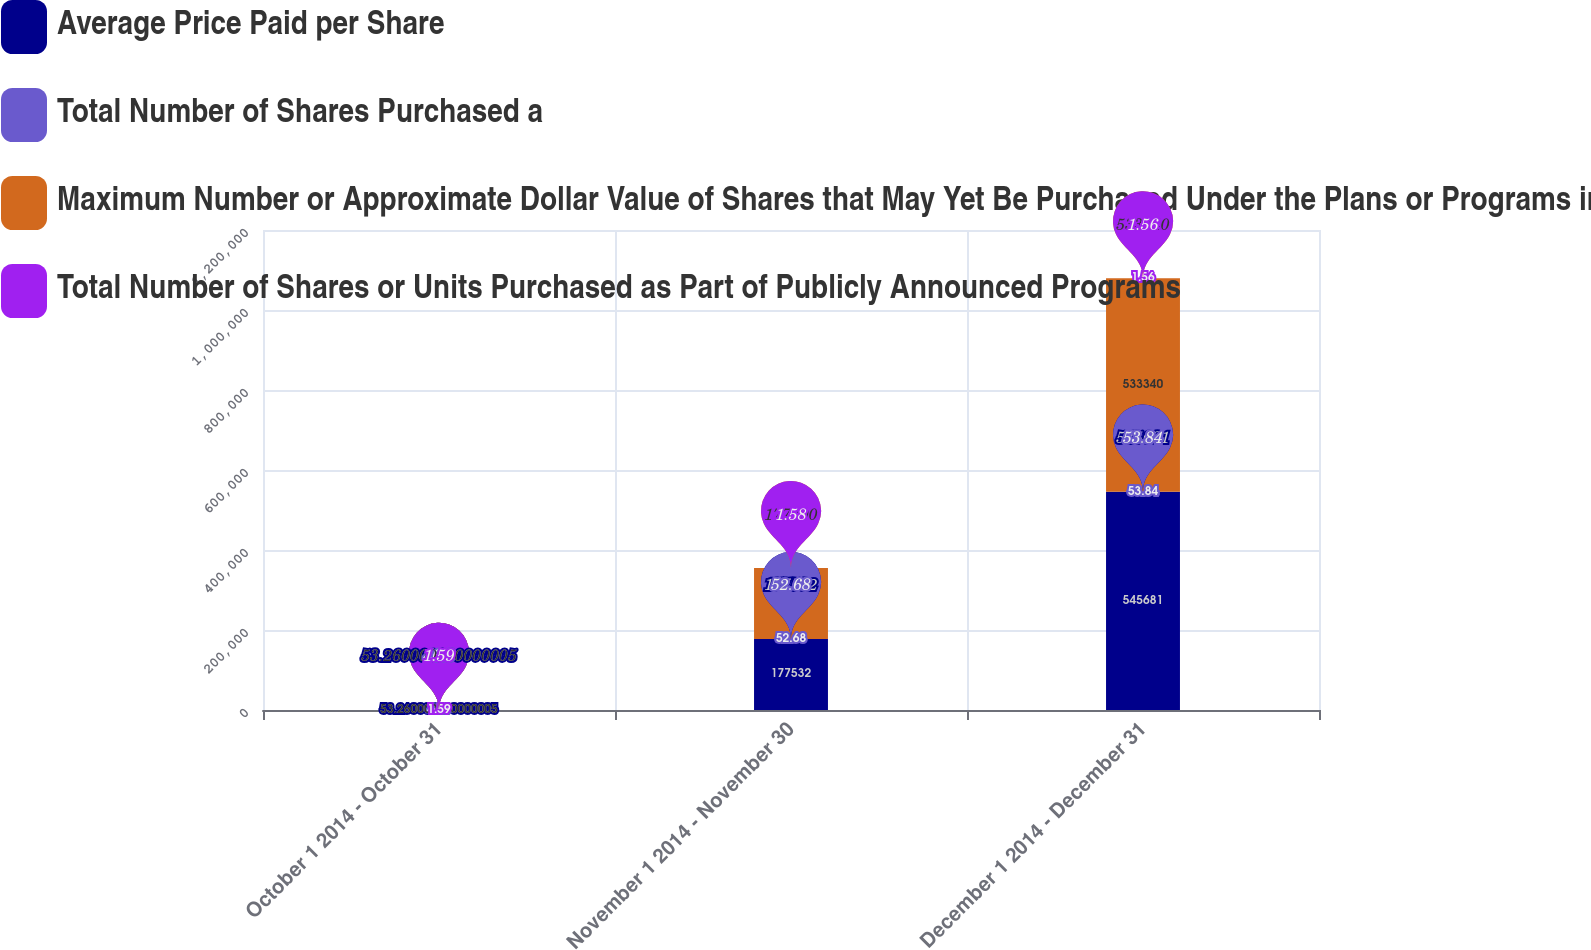<chart> <loc_0><loc_0><loc_500><loc_500><stacked_bar_chart><ecel><fcel>October 1 2014 - October 31<fcel>November 1 2014 - November 30<fcel>December 1 2014 - December 31<nl><fcel>Average Price Paid per Share<fcel>53.26<fcel>177532<fcel>545681<nl><fcel>Total Number of Shares Purchased a<fcel>46.8<fcel>52.68<fcel>53.84<nl><fcel>Maximum Number or Approximate Dollar Value of Shares that May Yet Be Purchased Under the Plans or Programs in billions<fcel>53.26<fcel>177300<fcel>533340<nl><fcel>Total Number of Shares or Units Purchased as Part of Publicly Announced Programs<fcel>1.59<fcel>1.58<fcel>1.56<nl></chart> 